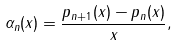<formula> <loc_0><loc_0><loc_500><loc_500>\alpha _ { n } ( x ) = \frac { p _ { n + 1 } ( x ) - p _ { n } ( x ) } { x } ,</formula> 